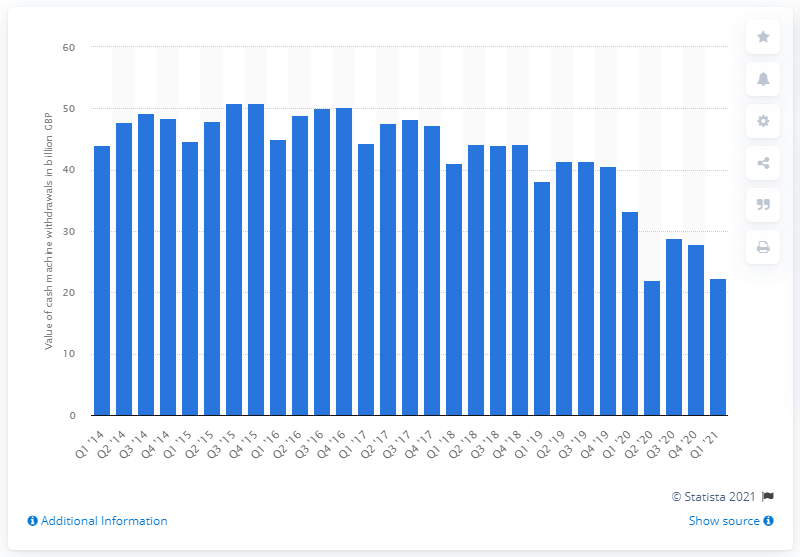Give some essential details in this illustration. As of the first quarter of 2021, the total value of cash machine withdrawals was 22.27. In the third quarter of 2015, a total of 50.8 pounds of cash machine withdrawals were recorded. 